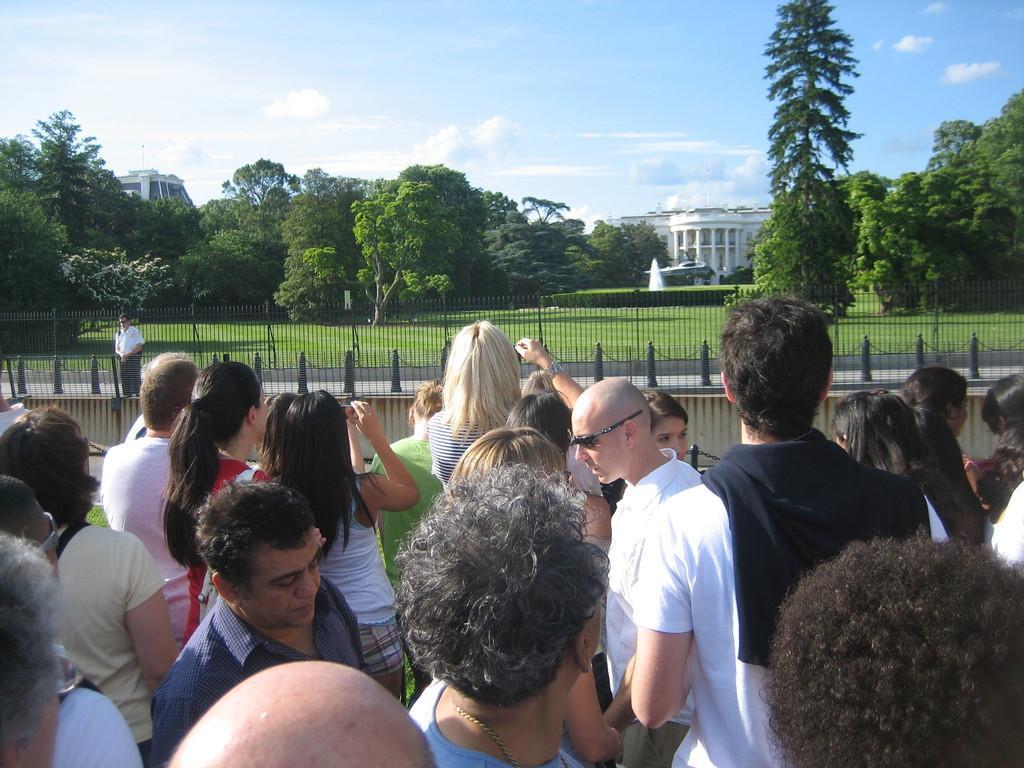Can you describe this image briefly? In this image I can see a group of people standing. I can see the railing. I can also see the grass. In the background, I can see the trees, buildings and clouds in the sky. 